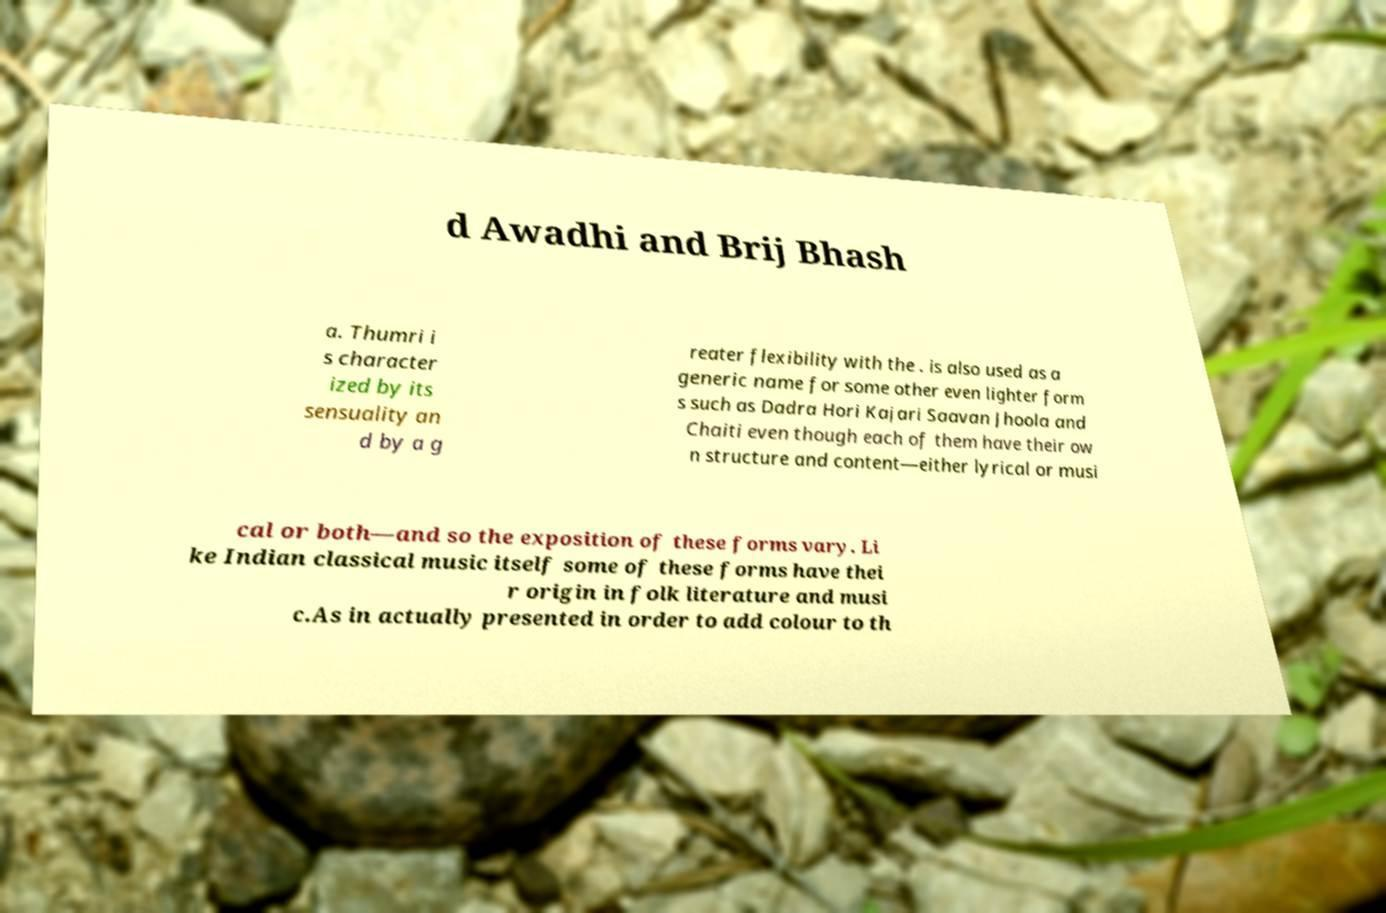Please identify and transcribe the text found in this image. d Awadhi and Brij Bhash a. Thumri i s character ized by its sensuality an d by a g reater flexibility with the . is also used as a generic name for some other even lighter form s such as Dadra Hori Kajari Saavan Jhoola and Chaiti even though each of them have their ow n structure and content—either lyrical or musi cal or both—and so the exposition of these forms vary. Li ke Indian classical music itself some of these forms have thei r origin in folk literature and musi c.As in actually presented in order to add colour to th 